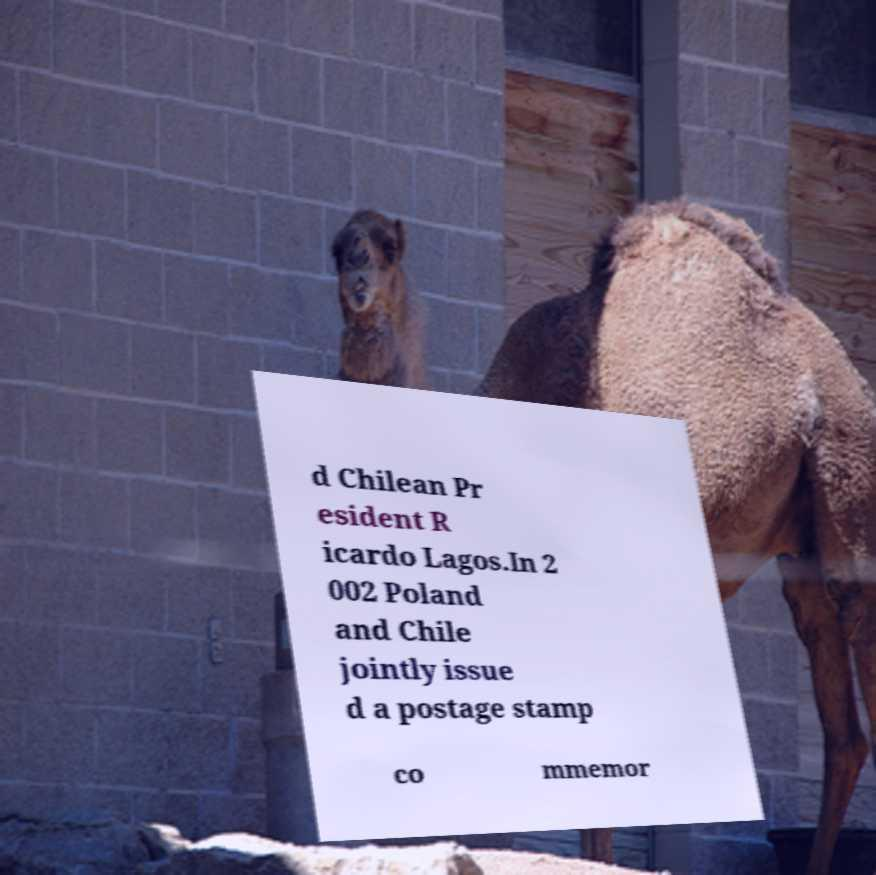Can you read and provide the text displayed in the image?This photo seems to have some interesting text. Can you extract and type it out for me? d Chilean Pr esident R icardo Lagos.In 2 002 Poland and Chile jointly issue d a postage stamp co mmemor 